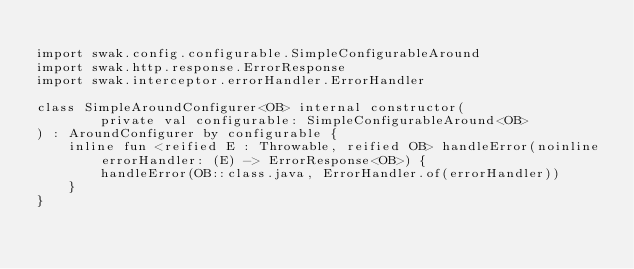<code> <loc_0><loc_0><loc_500><loc_500><_Kotlin_>
import swak.config.configurable.SimpleConfigurableAround
import swak.http.response.ErrorResponse
import swak.interceptor.errorHandler.ErrorHandler

class SimpleAroundConfigurer<OB> internal constructor(
        private val configurable: SimpleConfigurableAround<OB>
) : AroundConfigurer by configurable {
    inline fun <reified E : Throwable, reified OB> handleError(noinline errorHandler: (E) -> ErrorResponse<OB>) {
        handleError(OB::class.java, ErrorHandler.of(errorHandler))
    }
}</code> 